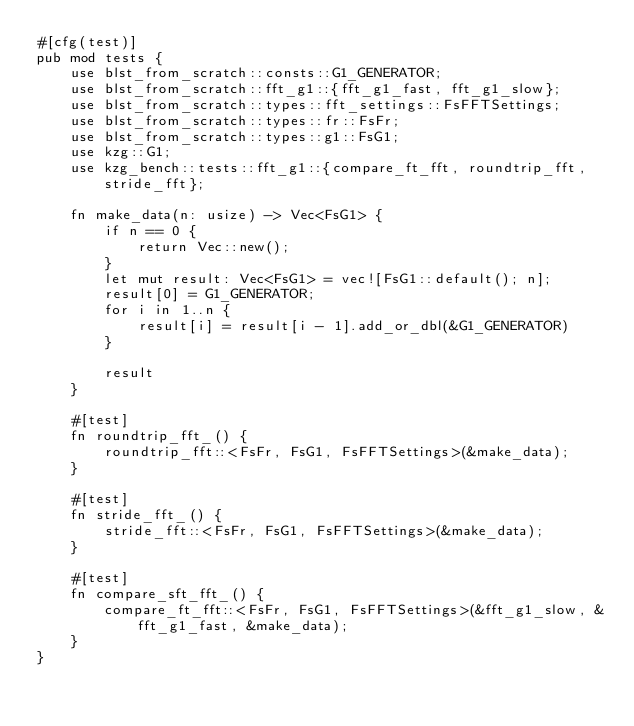Convert code to text. <code><loc_0><loc_0><loc_500><loc_500><_Rust_>#[cfg(test)]
pub mod tests {
    use blst_from_scratch::consts::G1_GENERATOR;
    use blst_from_scratch::fft_g1::{fft_g1_fast, fft_g1_slow};
    use blst_from_scratch::types::fft_settings::FsFFTSettings;
    use blst_from_scratch::types::fr::FsFr;
    use blst_from_scratch::types::g1::FsG1;
    use kzg::G1;
    use kzg_bench::tests::fft_g1::{compare_ft_fft, roundtrip_fft, stride_fft};

    fn make_data(n: usize) -> Vec<FsG1> {
        if n == 0 {
            return Vec::new();
        }
        let mut result: Vec<FsG1> = vec![FsG1::default(); n];
        result[0] = G1_GENERATOR;
        for i in 1..n {
            result[i] = result[i - 1].add_or_dbl(&G1_GENERATOR)
        }

        result
    }

    #[test]
    fn roundtrip_fft_() {
        roundtrip_fft::<FsFr, FsG1, FsFFTSettings>(&make_data);
    }

    #[test]
    fn stride_fft_() {
        stride_fft::<FsFr, FsG1, FsFFTSettings>(&make_data);
    }

    #[test]
    fn compare_sft_fft_() {
        compare_ft_fft::<FsFr, FsG1, FsFFTSettings>(&fft_g1_slow, &fft_g1_fast, &make_data);
    }
}
</code> 